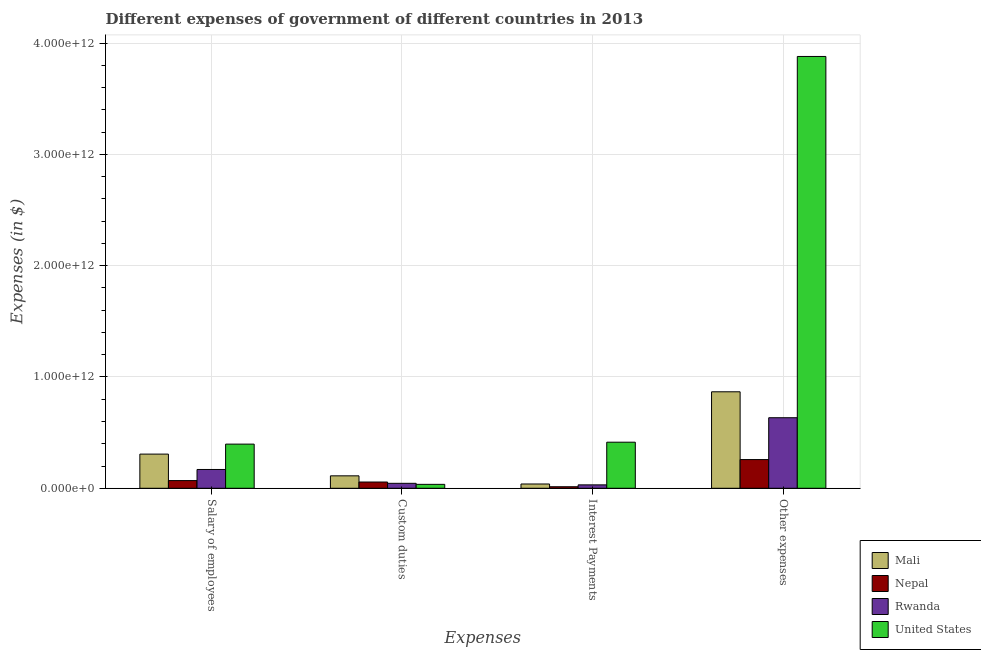How many groups of bars are there?
Make the answer very short. 4. How many bars are there on the 3rd tick from the right?
Provide a short and direct response. 4. What is the label of the 3rd group of bars from the left?
Offer a terse response. Interest Payments. What is the amount spent on salary of employees in Mali?
Give a very brief answer. 3.07e+11. Across all countries, what is the maximum amount spent on custom duties?
Your response must be concise. 1.12e+11. Across all countries, what is the minimum amount spent on interest payments?
Make the answer very short. 1.38e+1. In which country was the amount spent on interest payments minimum?
Give a very brief answer. Nepal. What is the total amount spent on custom duties in the graph?
Provide a succinct answer. 2.48e+11. What is the difference between the amount spent on interest payments in Rwanda and that in United States?
Ensure brevity in your answer.  -3.83e+11. What is the difference between the amount spent on custom duties in Rwanda and the amount spent on other expenses in Nepal?
Keep it short and to the point. -2.13e+11. What is the average amount spent on custom duties per country?
Your answer should be compact. 6.20e+1. What is the difference between the amount spent on interest payments and amount spent on custom duties in Mali?
Your response must be concise. -7.32e+1. What is the ratio of the amount spent on salary of employees in Rwanda to that in Mali?
Ensure brevity in your answer.  0.55. Is the amount spent on other expenses in Nepal less than that in Mali?
Your answer should be very brief. Yes. What is the difference between the highest and the second highest amount spent on other expenses?
Your response must be concise. 3.01e+12. What is the difference between the highest and the lowest amount spent on salary of employees?
Provide a succinct answer. 3.28e+11. Is the sum of the amount spent on custom duties in United States and Mali greater than the maximum amount spent on interest payments across all countries?
Make the answer very short. No. Is it the case that in every country, the sum of the amount spent on interest payments and amount spent on other expenses is greater than the sum of amount spent on custom duties and amount spent on salary of employees?
Provide a short and direct response. Yes. What does the 1st bar from the left in Salary of employees represents?
Your response must be concise. Mali. What does the 2nd bar from the right in Interest Payments represents?
Your answer should be very brief. Rwanda. How many countries are there in the graph?
Make the answer very short. 4. What is the difference between two consecutive major ticks on the Y-axis?
Your response must be concise. 1.00e+12. Does the graph contain any zero values?
Your response must be concise. No. Where does the legend appear in the graph?
Your answer should be compact. Bottom right. How are the legend labels stacked?
Your answer should be compact. Vertical. What is the title of the graph?
Offer a very short reply. Different expenses of government of different countries in 2013. Does "Denmark" appear as one of the legend labels in the graph?
Your answer should be compact. No. What is the label or title of the X-axis?
Your response must be concise. Expenses. What is the label or title of the Y-axis?
Provide a short and direct response. Expenses (in $). What is the Expenses (in $) in Mali in Salary of employees?
Offer a terse response. 3.07e+11. What is the Expenses (in $) of Nepal in Salary of employees?
Keep it short and to the point. 6.91e+1. What is the Expenses (in $) of Rwanda in Salary of employees?
Give a very brief answer. 1.69e+11. What is the Expenses (in $) in United States in Salary of employees?
Offer a very short reply. 3.97e+11. What is the Expenses (in $) in Mali in Custom duties?
Offer a very short reply. 1.12e+11. What is the Expenses (in $) in Nepal in Custom duties?
Your answer should be compact. 5.62e+1. What is the Expenses (in $) of Rwanda in Custom duties?
Offer a very short reply. 4.45e+1. What is the Expenses (in $) of United States in Custom duties?
Your answer should be compact. 3.53e+1. What is the Expenses (in $) of Mali in Interest Payments?
Keep it short and to the point. 3.86e+1. What is the Expenses (in $) in Nepal in Interest Payments?
Your answer should be very brief. 1.38e+1. What is the Expenses (in $) of Rwanda in Interest Payments?
Offer a terse response. 3.07e+1. What is the Expenses (in $) in United States in Interest Payments?
Your answer should be very brief. 4.14e+11. What is the Expenses (in $) of Mali in Other expenses?
Offer a terse response. 8.67e+11. What is the Expenses (in $) in Nepal in Other expenses?
Your answer should be compact. 2.58e+11. What is the Expenses (in $) of Rwanda in Other expenses?
Make the answer very short. 6.34e+11. What is the Expenses (in $) in United States in Other expenses?
Provide a succinct answer. 3.88e+12. Across all Expenses, what is the maximum Expenses (in $) of Mali?
Provide a short and direct response. 8.67e+11. Across all Expenses, what is the maximum Expenses (in $) in Nepal?
Offer a very short reply. 2.58e+11. Across all Expenses, what is the maximum Expenses (in $) of Rwanda?
Your answer should be very brief. 6.34e+11. Across all Expenses, what is the maximum Expenses (in $) of United States?
Give a very brief answer. 3.88e+12. Across all Expenses, what is the minimum Expenses (in $) of Mali?
Give a very brief answer. 3.86e+1. Across all Expenses, what is the minimum Expenses (in $) in Nepal?
Your response must be concise. 1.38e+1. Across all Expenses, what is the minimum Expenses (in $) of Rwanda?
Provide a short and direct response. 3.07e+1. Across all Expenses, what is the minimum Expenses (in $) in United States?
Give a very brief answer. 3.53e+1. What is the total Expenses (in $) of Mali in the graph?
Your answer should be compact. 1.32e+12. What is the total Expenses (in $) in Nepal in the graph?
Offer a terse response. 3.97e+11. What is the total Expenses (in $) of Rwanda in the graph?
Ensure brevity in your answer.  8.78e+11. What is the total Expenses (in $) in United States in the graph?
Your answer should be compact. 4.73e+12. What is the difference between the Expenses (in $) in Mali in Salary of employees and that in Custom duties?
Provide a short and direct response. 1.95e+11. What is the difference between the Expenses (in $) in Nepal in Salary of employees and that in Custom duties?
Offer a terse response. 1.29e+1. What is the difference between the Expenses (in $) in Rwanda in Salary of employees and that in Custom duties?
Make the answer very short. 1.24e+11. What is the difference between the Expenses (in $) in United States in Salary of employees and that in Custom duties?
Provide a short and direct response. 3.62e+11. What is the difference between the Expenses (in $) of Mali in Salary of employees and that in Interest Payments?
Offer a very short reply. 2.68e+11. What is the difference between the Expenses (in $) of Nepal in Salary of employees and that in Interest Payments?
Your answer should be compact. 5.53e+1. What is the difference between the Expenses (in $) in Rwanda in Salary of employees and that in Interest Payments?
Ensure brevity in your answer.  1.38e+11. What is the difference between the Expenses (in $) of United States in Salary of employees and that in Interest Payments?
Your answer should be compact. -1.73e+1. What is the difference between the Expenses (in $) in Mali in Salary of employees and that in Other expenses?
Your answer should be compact. -5.60e+11. What is the difference between the Expenses (in $) in Nepal in Salary of employees and that in Other expenses?
Keep it short and to the point. -1.89e+11. What is the difference between the Expenses (in $) in Rwanda in Salary of employees and that in Other expenses?
Your answer should be very brief. -4.65e+11. What is the difference between the Expenses (in $) in United States in Salary of employees and that in Other expenses?
Make the answer very short. -3.48e+12. What is the difference between the Expenses (in $) in Mali in Custom duties and that in Interest Payments?
Your response must be concise. 7.32e+1. What is the difference between the Expenses (in $) of Nepal in Custom duties and that in Interest Payments?
Keep it short and to the point. 4.24e+1. What is the difference between the Expenses (in $) of Rwanda in Custom duties and that in Interest Payments?
Your answer should be compact. 1.38e+1. What is the difference between the Expenses (in $) in United States in Custom duties and that in Interest Payments?
Provide a short and direct response. -3.79e+11. What is the difference between the Expenses (in $) in Mali in Custom duties and that in Other expenses?
Provide a succinct answer. -7.55e+11. What is the difference between the Expenses (in $) of Nepal in Custom duties and that in Other expenses?
Your answer should be compact. -2.02e+11. What is the difference between the Expenses (in $) of Rwanda in Custom duties and that in Other expenses?
Your answer should be very brief. -5.89e+11. What is the difference between the Expenses (in $) of United States in Custom duties and that in Other expenses?
Your response must be concise. -3.84e+12. What is the difference between the Expenses (in $) of Mali in Interest Payments and that in Other expenses?
Offer a very short reply. -8.28e+11. What is the difference between the Expenses (in $) of Nepal in Interest Payments and that in Other expenses?
Provide a succinct answer. -2.44e+11. What is the difference between the Expenses (in $) in Rwanda in Interest Payments and that in Other expenses?
Your response must be concise. -6.03e+11. What is the difference between the Expenses (in $) of United States in Interest Payments and that in Other expenses?
Keep it short and to the point. -3.47e+12. What is the difference between the Expenses (in $) of Mali in Salary of employees and the Expenses (in $) of Nepal in Custom duties?
Provide a succinct answer. 2.51e+11. What is the difference between the Expenses (in $) of Mali in Salary of employees and the Expenses (in $) of Rwanda in Custom duties?
Your response must be concise. 2.63e+11. What is the difference between the Expenses (in $) in Mali in Salary of employees and the Expenses (in $) in United States in Custom duties?
Offer a terse response. 2.72e+11. What is the difference between the Expenses (in $) in Nepal in Salary of employees and the Expenses (in $) in Rwanda in Custom duties?
Offer a terse response. 2.46e+1. What is the difference between the Expenses (in $) in Nepal in Salary of employees and the Expenses (in $) in United States in Custom duties?
Give a very brief answer. 3.38e+1. What is the difference between the Expenses (in $) in Rwanda in Salary of employees and the Expenses (in $) in United States in Custom duties?
Your answer should be very brief. 1.34e+11. What is the difference between the Expenses (in $) of Mali in Salary of employees and the Expenses (in $) of Nepal in Interest Payments?
Offer a terse response. 2.93e+11. What is the difference between the Expenses (in $) of Mali in Salary of employees and the Expenses (in $) of Rwanda in Interest Payments?
Your answer should be very brief. 2.76e+11. What is the difference between the Expenses (in $) of Mali in Salary of employees and the Expenses (in $) of United States in Interest Payments?
Provide a succinct answer. -1.07e+11. What is the difference between the Expenses (in $) in Nepal in Salary of employees and the Expenses (in $) in Rwanda in Interest Payments?
Offer a terse response. 3.84e+1. What is the difference between the Expenses (in $) in Nepal in Salary of employees and the Expenses (in $) in United States in Interest Payments?
Ensure brevity in your answer.  -3.45e+11. What is the difference between the Expenses (in $) in Rwanda in Salary of employees and the Expenses (in $) in United States in Interest Payments?
Your answer should be compact. -2.45e+11. What is the difference between the Expenses (in $) in Mali in Salary of employees and the Expenses (in $) in Nepal in Other expenses?
Provide a succinct answer. 4.91e+1. What is the difference between the Expenses (in $) of Mali in Salary of employees and the Expenses (in $) of Rwanda in Other expenses?
Your answer should be very brief. -3.27e+11. What is the difference between the Expenses (in $) of Mali in Salary of employees and the Expenses (in $) of United States in Other expenses?
Make the answer very short. -3.57e+12. What is the difference between the Expenses (in $) in Nepal in Salary of employees and the Expenses (in $) in Rwanda in Other expenses?
Ensure brevity in your answer.  -5.65e+11. What is the difference between the Expenses (in $) of Nepal in Salary of employees and the Expenses (in $) of United States in Other expenses?
Your response must be concise. -3.81e+12. What is the difference between the Expenses (in $) of Rwanda in Salary of employees and the Expenses (in $) of United States in Other expenses?
Make the answer very short. -3.71e+12. What is the difference between the Expenses (in $) in Mali in Custom duties and the Expenses (in $) in Nepal in Interest Payments?
Offer a very short reply. 9.80e+1. What is the difference between the Expenses (in $) of Mali in Custom duties and the Expenses (in $) of Rwanda in Interest Payments?
Provide a succinct answer. 8.11e+1. What is the difference between the Expenses (in $) in Mali in Custom duties and the Expenses (in $) in United States in Interest Payments?
Your answer should be very brief. -3.02e+11. What is the difference between the Expenses (in $) in Nepal in Custom duties and the Expenses (in $) in Rwanda in Interest Payments?
Ensure brevity in your answer.  2.55e+1. What is the difference between the Expenses (in $) of Nepal in Custom duties and the Expenses (in $) of United States in Interest Payments?
Provide a succinct answer. -3.58e+11. What is the difference between the Expenses (in $) in Rwanda in Custom duties and the Expenses (in $) in United States in Interest Payments?
Provide a succinct answer. -3.70e+11. What is the difference between the Expenses (in $) in Mali in Custom duties and the Expenses (in $) in Nepal in Other expenses?
Provide a short and direct response. -1.46e+11. What is the difference between the Expenses (in $) of Mali in Custom duties and the Expenses (in $) of Rwanda in Other expenses?
Your answer should be very brief. -5.22e+11. What is the difference between the Expenses (in $) in Mali in Custom duties and the Expenses (in $) in United States in Other expenses?
Offer a terse response. -3.77e+12. What is the difference between the Expenses (in $) in Nepal in Custom duties and the Expenses (in $) in Rwanda in Other expenses?
Provide a succinct answer. -5.78e+11. What is the difference between the Expenses (in $) of Nepal in Custom duties and the Expenses (in $) of United States in Other expenses?
Provide a succinct answer. -3.82e+12. What is the difference between the Expenses (in $) in Rwanda in Custom duties and the Expenses (in $) in United States in Other expenses?
Provide a succinct answer. -3.84e+12. What is the difference between the Expenses (in $) of Mali in Interest Payments and the Expenses (in $) of Nepal in Other expenses?
Offer a terse response. -2.19e+11. What is the difference between the Expenses (in $) in Mali in Interest Payments and the Expenses (in $) in Rwanda in Other expenses?
Your answer should be compact. -5.95e+11. What is the difference between the Expenses (in $) of Mali in Interest Payments and the Expenses (in $) of United States in Other expenses?
Offer a very short reply. -3.84e+12. What is the difference between the Expenses (in $) of Nepal in Interest Payments and the Expenses (in $) of Rwanda in Other expenses?
Offer a very short reply. -6.20e+11. What is the difference between the Expenses (in $) in Nepal in Interest Payments and the Expenses (in $) in United States in Other expenses?
Make the answer very short. -3.87e+12. What is the difference between the Expenses (in $) in Rwanda in Interest Payments and the Expenses (in $) in United States in Other expenses?
Offer a terse response. -3.85e+12. What is the average Expenses (in $) in Mali per Expenses?
Your response must be concise. 3.31e+11. What is the average Expenses (in $) of Nepal per Expenses?
Give a very brief answer. 9.93e+1. What is the average Expenses (in $) of Rwanda per Expenses?
Your response must be concise. 2.20e+11. What is the average Expenses (in $) of United States per Expenses?
Offer a very short reply. 1.18e+12. What is the difference between the Expenses (in $) of Mali and Expenses (in $) of Nepal in Salary of employees?
Make the answer very short. 2.38e+11. What is the difference between the Expenses (in $) in Mali and Expenses (in $) in Rwanda in Salary of employees?
Provide a short and direct response. 1.38e+11. What is the difference between the Expenses (in $) in Mali and Expenses (in $) in United States in Salary of employees?
Ensure brevity in your answer.  -8.98e+1. What is the difference between the Expenses (in $) in Nepal and Expenses (in $) in Rwanda in Salary of employees?
Your response must be concise. -9.98e+1. What is the difference between the Expenses (in $) of Nepal and Expenses (in $) of United States in Salary of employees?
Give a very brief answer. -3.28e+11. What is the difference between the Expenses (in $) of Rwanda and Expenses (in $) of United States in Salary of employees?
Give a very brief answer. -2.28e+11. What is the difference between the Expenses (in $) in Mali and Expenses (in $) in Nepal in Custom duties?
Your answer should be very brief. 5.55e+1. What is the difference between the Expenses (in $) of Mali and Expenses (in $) of Rwanda in Custom duties?
Provide a short and direct response. 6.73e+1. What is the difference between the Expenses (in $) of Mali and Expenses (in $) of United States in Custom duties?
Ensure brevity in your answer.  7.65e+1. What is the difference between the Expenses (in $) of Nepal and Expenses (in $) of Rwanda in Custom duties?
Your answer should be very brief. 1.17e+1. What is the difference between the Expenses (in $) of Nepal and Expenses (in $) of United States in Custom duties?
Ensure brevity in your answer.  2.09e+1. What is the difference between the Expenses (in $) of Rwanda and Expenses (in $) of United States in Custom duties?
Provide a succinct answer. 9.20e+09. What is the difference between the Expenses (in $) in Mali and Expenses (in $) in Nepal in Interest Payments?
Offer a very short reply. 2.47e+1. What is the difference between the Expenses (in $) in Mali and Expenses (in $) in Rwanda in Interest Payments?
Your answer should be compact. 7.86e+09. What is the difference between the Expenses (in $) of Mali and Expenses (in $) of United States in Interest Payments?
Keep it short and to the point. -3.76e+11. What is the difference between the Expenses (in $) in Nepal and Expenses (in $) in Rwanda in Interest Payments?
Provide a succinct answer. -1.69e+1. What is the difference between the Expenses (in $) of Nepal and Expenses (in $) of United States in Interest Payments?
Make the answer very short. -4.00e+11. What is the difference between the Expenses (in $) in Rwanda and Expenses (in $) in United States in Interest Payments?
Offer a terse response. -3.83e+11. What is the difference between the Expenses (in $) of Mali and Expenses (in $) of Nepal in Other expenses?
Make the answer very short. 6.09e+11. What is the difference between the Expenses (in $) of Mali and Expenses (in $) of Rwanda in Other expenses?
Offer a terse response. 2.33e+11. What is the difference between the Expenses (in $) in Mali and Expenses (in $) in United States in Other expenses?
Provide a succinct answer. -3.01e+12. What is the difference between the Expenses (in $) of Nepal and Expenses (in $) of Rwanda in Other expenses?
Provide a short and direct response. -3.76e+11. What is the difference between the Expenses (in $) of Nepal and Expenses (in $) of United States in Other expenses?
Keep it short and to the point. -3.62e+12. What is the difference between the Expenses (in $) in Rwanda and Expenses (in $) in United States in Other expenses?
Your answer should be very brief. -3.25e+12. What is the ratio of the Expenses (in $) in Mali in Salary of employees to that in Custom duties?
Your answer should be compact. 2.75. What is the ratio of the Expenses (in $) of Nepal in Salary of employees to that in Custom duties?
Your response must be concise. 1.23. What is the ratio of the Expenses (in $) in Rwanda in Salary of employees to that in Custom duties?
Give a very brief answer. 3.8. What is the ratio of the Expenses (in $) of United States in Salary of employees to that in Custom duties?
Provide a succinct answer. 11.24. What is the ratio of the Expenses (in $) of Mali in Salary of employees to that in Interest Payments?
Provide a short and direct response. 7.96. What is the ratio of the Expenses (in $) of Nepal in Salary of employees to that in Interest Payments?
Your answer should be very brief. 5.01. What is the ratio of the Expenses (in $) of Rwanda in Salary of employees to that in Interest Payments?
Offer a very short reply. 5.5. What is the ratio of the Expenses (in $) of United States in Salary of employees to that in Interest Payments?
Offer a terse response. 0.96. What is the ratio of the Expenses (in $) of Mali in Salary of employees to that in Other expenses?
Your response must be concise. 0.35. What is the ratio of the Expenses (in $) of Nepal in Salary of employees to that in Other expenses?
Your response must be concise. 0.27. What is the ratio of the Expenses (in $) in Rwanda in Salary of employees to that in Other expenses?
Your response must be concise. 0.27. What is the ratio of the Expenses (in $) in United States in Salary of employees to that in Other expenses?
Provide a short and direct response. 0.1. What is the ratio of the Expenses (in $) in Mali in Custom duties to that in Interest Payments?
Ensure brevity in your answer.  2.9. What is the ratio of the Expenses (in $) in Nepal in Custom duties to that in Interest Payments?
Provide a short and direct response. 4.07. What is the ratio of the Expenses (in $) in Rwanda in Custom duties to that in Interest Payments?
Provide a succinct answer. 1.45. What is the ratio of the Expenses (in $) in United States in Custom duties to that in Interest Payments?
Offer a very short reply. 0.09. What is the ratio of the Expenses (in $) of Mali in Custom duties to that in Other expenses?
Give a very brief answer. 0.13. What is the ratio of the Expenses (in $) in Nepal in Custom duties to that in Other expenses?
Give a very brief answer. 0.22. What is the ratio of the Expenses (in $) in Rwanda in Custom duties to that in Other expenses?
Give a very brief answer. 0.07. What is the ratio of the Expenses (in $) in United States in Custom duties to that in Other expenses?
Your answer should be very brief. 0.01. What is the ratio of the Expenses (in $) in Mali in Interest Payments to that in Other expenses?
Provide a succinct answer. 0.04. What is the ratio of the Expenses (in $) of Nepal in Interest Payments to that in Other expenses?
Provide a succinct answer. 0.05. What is the ratio of the Expenses (in $) of Rwanda in Interest Payments to that in Other expenses?
Keep it short and to the point. 0.05. What is the ratio of the Expenses (in $) in United States in Interest Payments to that in Other expenses?
Offer a very short reply. 0.11. What is the difference between the highest and the second highest Expenses (in $) in Mali?
Ensure brevity in your answer.  5.60e+11. What is the difference between the highest and the second highest Expenses (in $) in Nepal?
Ensure brevity in your answer.  1.89e+11. What is the difference between the highest and the second highest Expenses (in $) in Rwanda?
Your answer should be very brief. 4.65e+11. What is the difference between the highest and the second highest Expenses (in $) of United States?
Your answer should be very brief. 3.47e+12. What is the difference between the highest and the lowest Expenses (in $) of Mali?
Ensure brevity in your answer.  8.28e+11. What is the difference between the highest and the lowest Expenses (in $) of Nepal?
Make the answer very short. 2.44e+11. What is the difference between the highest and the lowest Expenses (in $) in Rwanda?
Make the answer very short. 6.03e+11. What is the difference between the highest and the lowest Expenses (in $) of United States?
Your answer should be very brief. 3.84e+12. 